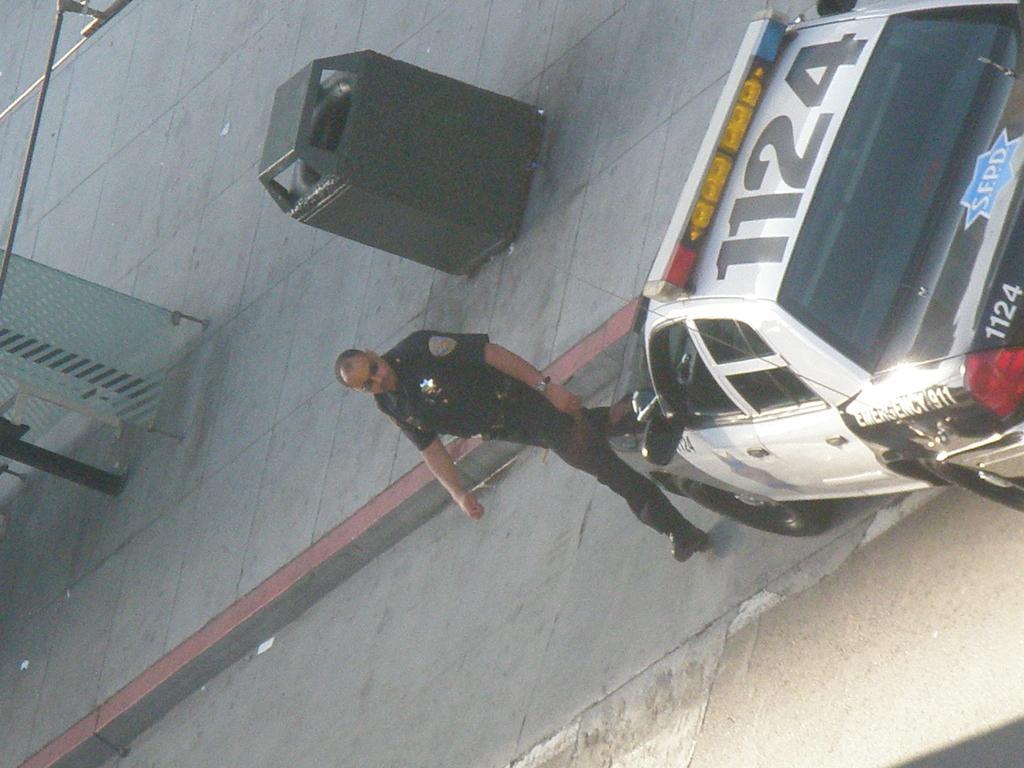Describe this image in one or two sentences. This is an outside view. On the right side there is a car on the road. Beside the car there is man wearing uniform and crossing the road. At the top of the image there is a dustbin on the ground. On the left side there is a pole and a glass. 